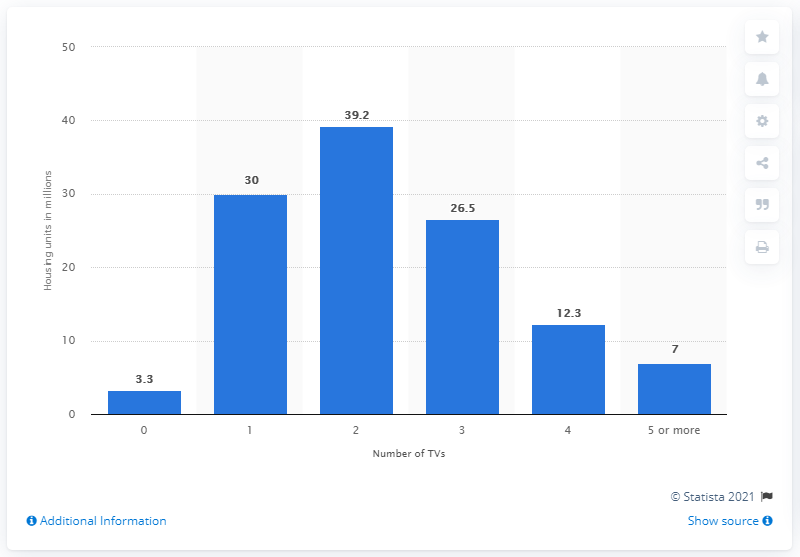Draw attention to some important aspects in this diagram. In 2015, approximately 39.2% of housing units in the United States had two or more televisions. 